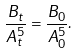Convert formula to latex. <formula><loc_0><loc_0><loc_500><loc_500>\frac { B _ { t } } { A _ { t } ^ { 5 } } = \frac { B _ { 0 } } { A _ { 0 } ^ { 5 } } .</formula> 